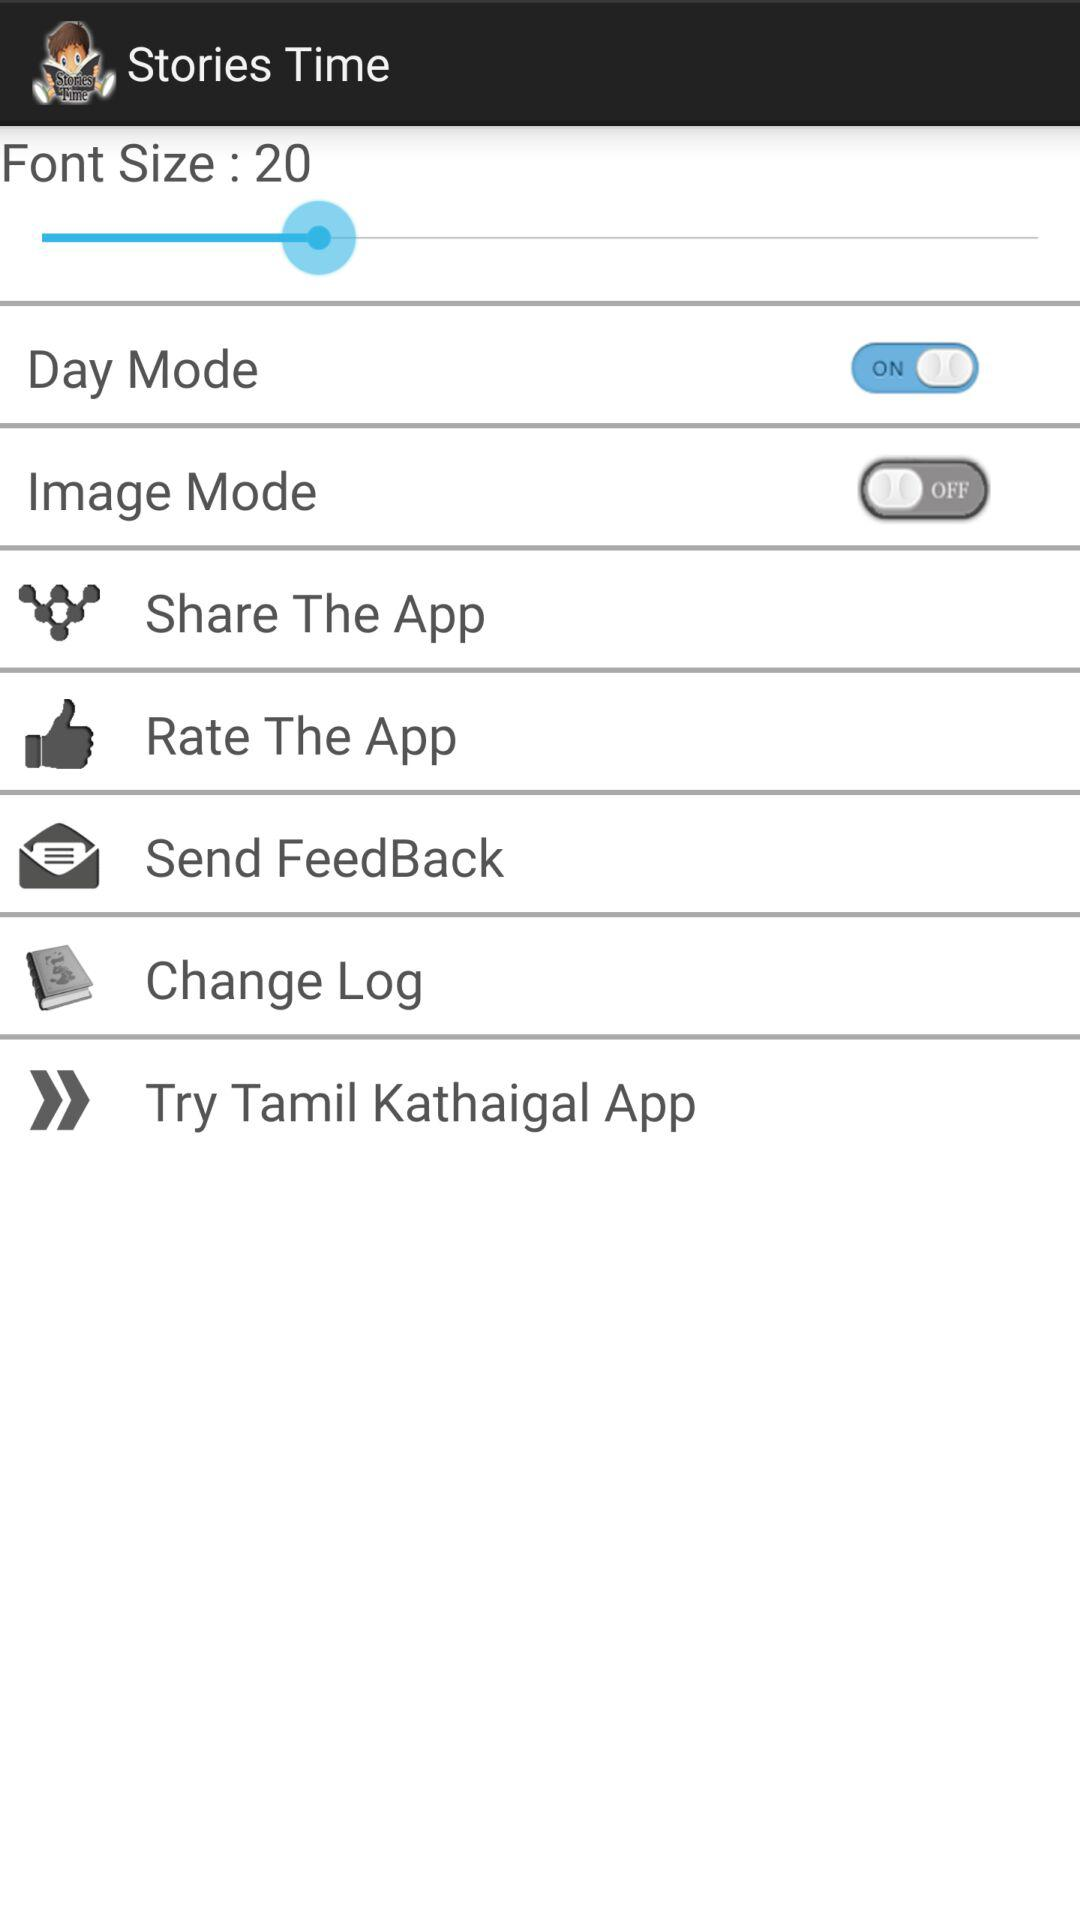What is the status of "Image Mode"? The status of "Image Mode" is "off". 